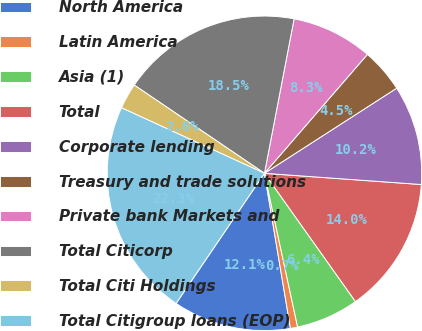Convert chart. <chart><loc_0><loc_0><loc_500><loc_500><pie_chart><fcel>North America<fcel>Latin America<fcel>Asia (1)<fcel>Total<fcel>Corporate lending<fcel>Treasury and trade solutions<fcel>Private bank Markets and<fcel>Total Citicorp<fcel>Total Citi Holdings<fcel>Total Citigroup loans (EOP)<nl><fcel>12.14%<fcel>0.74%<fcel>6.44%<fcel>14.04%<fcel>10.24%<fcel>4.54%<fcel>8.34%<fcel>18.54%<fcel>2.64%<fcel>22.34%<nl></chart> 